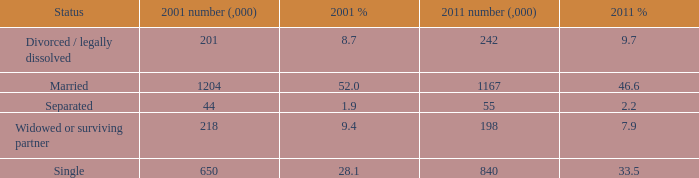What si the 2011 number (,000) when 2001 % is 28.1? 840.0. Help me parse the entirety of this table. {'header': ['Status', '2001 number (,000)', '2001 %', '2011 number (,000)', '2011 %'], 'rows': [['Divorced / legally dissolved', '201', '8.7', '242', '9.7'], ['Married', '1204', '52.0', '1167', '46.6'], ['Separated', '44', '1.9', '55', '2.2'], ['Widowed or surviving partner', '218', '9.4', '198', '7.9'], ['Single', '650', '28.1', '840', '33.5']]} 